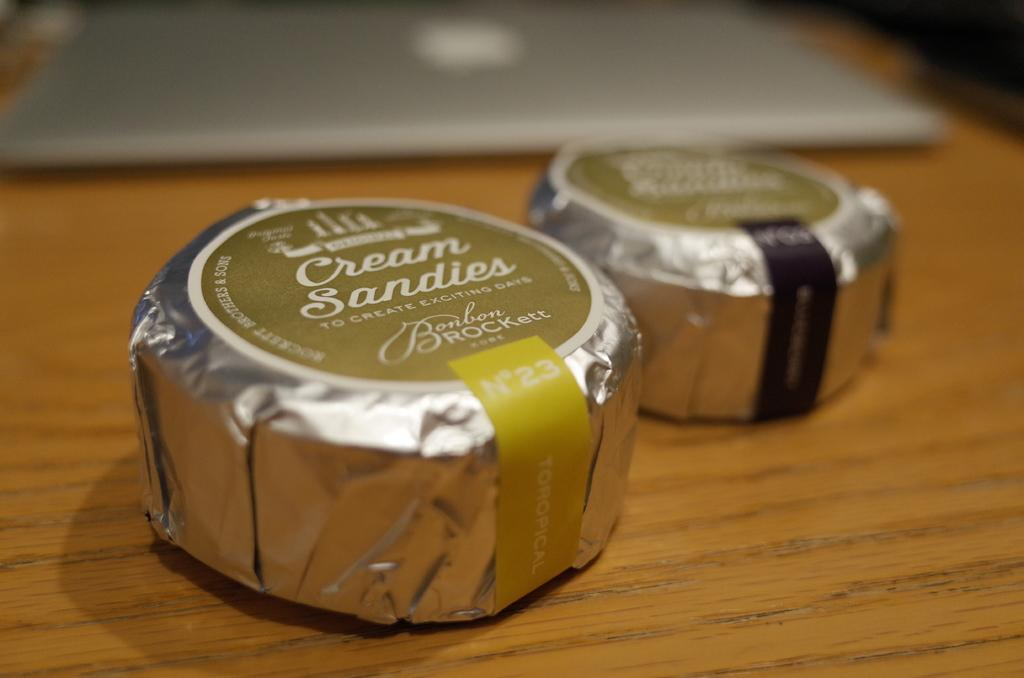How many candies are visible in the image? There are two candies in the image. What electronic device can be seen in the image? There is a laptop on a table in the image. Is the laptop being used to drive a car in the image? No, there is no car or driving activity depicted in the image. What type of mineral is present on the laptop in the image? There is no mineral, such as quartz, present on the laptop in the image. 